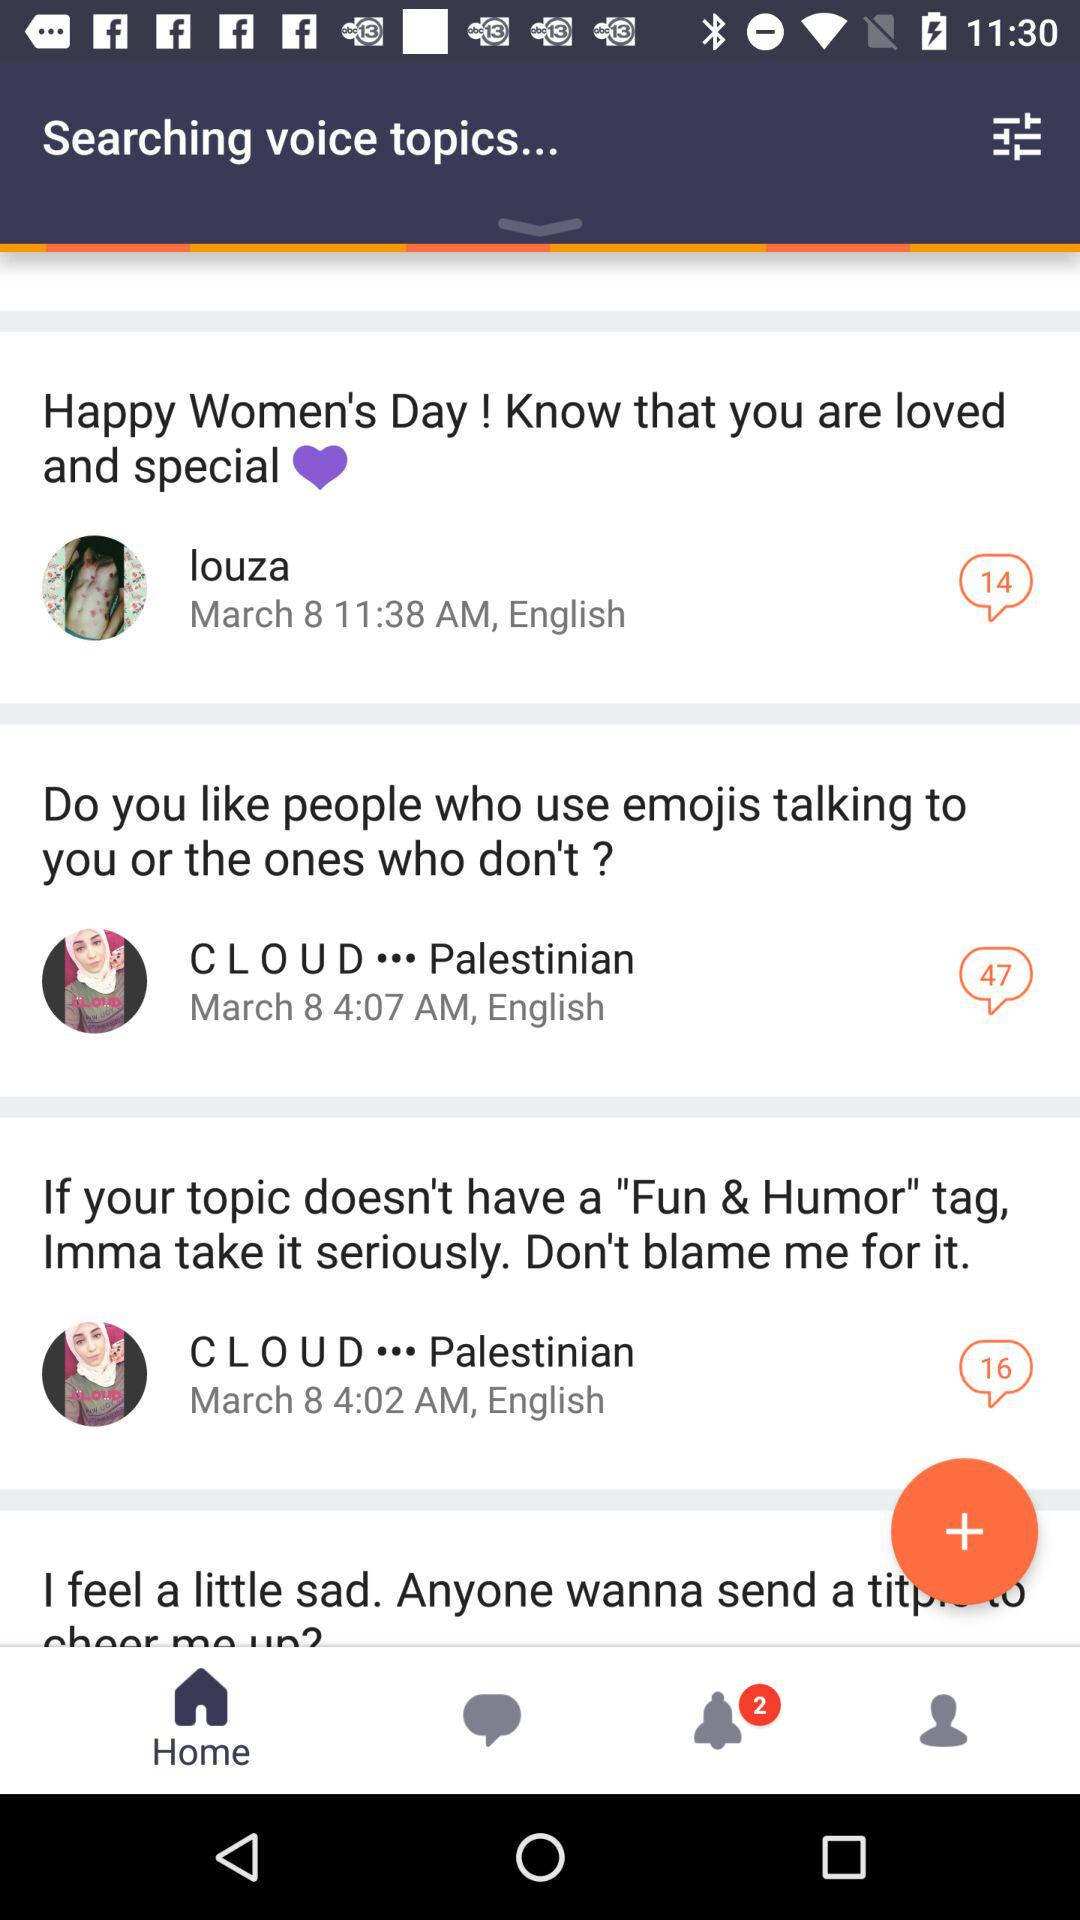When and at what time did Louza post about Women's Day? Louza posted about Women's Day on March 8 at 11:38 a.m. 